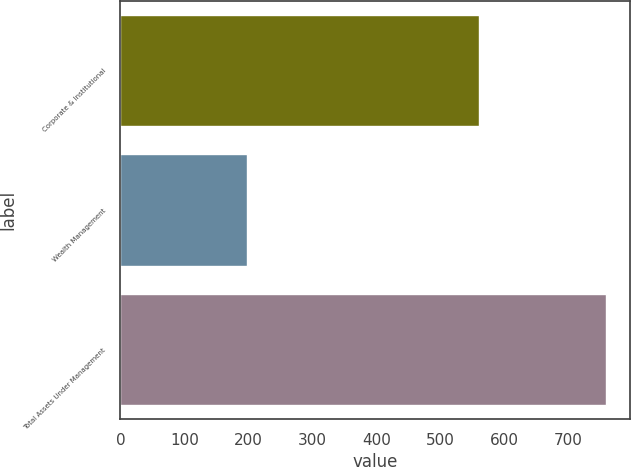<chart> <loc_0><loc_0><loc_500><loc_500><bar_chart><fcel>Corporate & Institutional<fcel>Wealth Management<fcel>Total Assets Under Management<nl><fcel>561.2<fcel>197.7<fcel>758.9<nl></chart> 